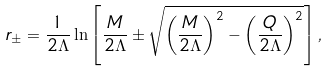Convert formula to latex. <formula><loc_0><loc_0><loc_500><loc_500>r _ { \pm } = \frac { 1 } { 2 \Lambda } \ln \left [ \frac { M } { 2 \Lambda } \pm \sqrt { \left ( \frac { M } { 2 \Lambda } \right ) ^ { 2 } - \left ( \frac { Q } { 2 \Lambda } \right ) ^ { 2 } } \right ] ,</formula> 